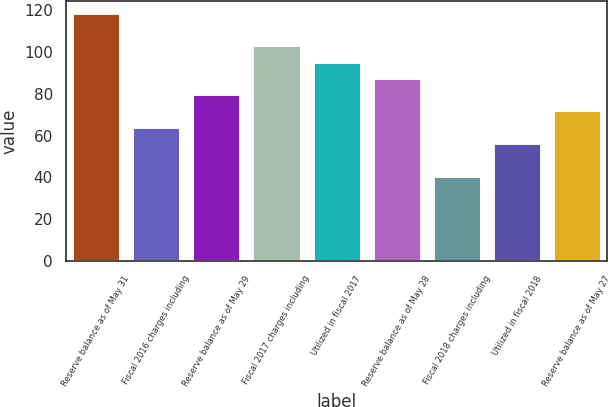Convert chart. <chart><loc_0><loc_0><loc_500><loc_500><bar_chart><fcel>Reserve balance as of May 31<fcel>Fiscal 2016 charges including<fcel>Reserve balance as of May 29<fcel>Fiscal 2017 charges including<fcel>Utilized in fiscal 2017<fcel>Reserve balance as of May 28<fcel>Fiscal 2018 charges including<fcel>Utilized in fiscal 2018<fcel>Reserve balance as of May 27<nl><fcel>118.6<fcel>64.38<fcel>79.94<fcel>103.28<fcel>95.5<fcel>87.72<fcel>40.8<fcel>56.6<fcel>72.16<nl></chart> 